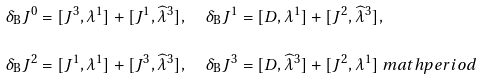Convert formula to latex. <formula><loc_0><loc_0><loc_500><loc_500>\delta _ { \text {B} } J ^ { 0 } & = [ J ^ { 3 } , \lambda ^ { 1 } ] + [ J ^ { 1 } , \widehat { \lambda } ^ { 3 } ] , \quad \delta _ { \text {B} } J ^ { 1 } = [ D , \lambda ^ { 1 } ] + [ J ^ { 2 } , \widehat { \lambda } ^ { 3 } ] , \\ \delta _ { \text {B} } J ^ { 2 } & = [ J ^ { 1 } , \lambda ^ { 1 } ] + [ J ^ { 3 } , \widehat { \lambda } ^ { 3 } ] , \quad \delta _ { \text {B} } J ^ { 3 } = [ D , \widehat { \lambda } ^ { 3 } ] + [ J ^ { 2 } , \lambda ^ { 1 } ] \ m a t h p e r i o d</formula> 